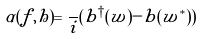Convert formula to latex. <formula><loc_0><loc_0><loc_500><loc_500>\alpha ( f , h ) = \frac { } { i } ( b ^ { \dagger } ( w ) - b ( w ^ { * } ) )</formula> 